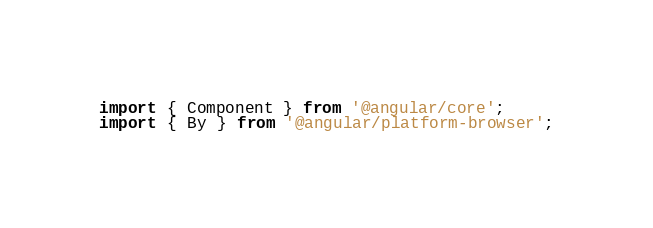Convert code to text. <code><loc_0><loc_0><loc_500><loc_500><_TypeScript_>import { Component } from '@angular/core';
import { By } from '@angular/platform-browser';</code> 